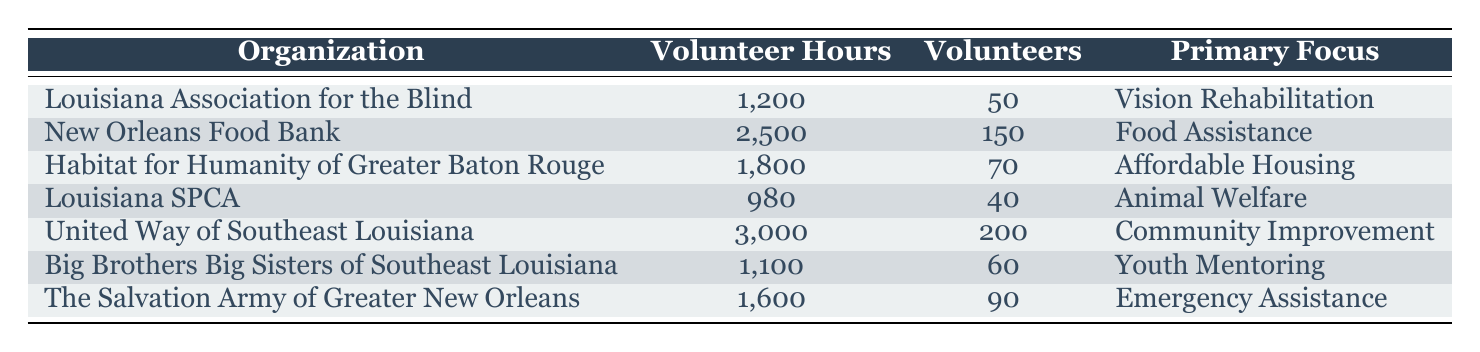What organization contributed the most volunteer hours? The table shows the total volunteer hours for each organization. By comparing them, United Way of Southeast Louisiana has the highest total of 3,000 volunteer hours.
Answer: United Way of Southeast Louisiana How many volunteer hours did the Louisiana SPCA contribute? According to the table, the Louisiana SPCA contributed a total of 980 volunteer hours.
Answer: 980 What is the total number of volunteers across all organizations? To find the total number of volunteers, we add the number of volunteers from each organization: 50 + 150 + 70 + 40 + 200 + 60 + 90 = 660.
Answer: 660 Which organization has the lowest number of volunteer hours? By reviewing the total volunteer hours listed, Louisiana SPCA has the lowest with 980 hours.
Answer: Louisiana SPCA Is it true that Habitat for Humanity of Greater Baton Rouge has more volunteers than the Louisiana SPCA? The table shows that Habitat for Humanity has 70 volunteers while Louisiana SPCA has 40 volunteers. Therefore, it is true that Habitat for Humanity has more volunteers.
Answer: Yes What is the average number of volunteer hours contributed by the organizations in the table? First, we need to sum the total volunteer hours: 1200 + 2500 + 1800 + 980 + 3000 + 1100 + 1600 = 13180. Then, we divide by the number of organizations, which is 7, giving us an average of 13180 / 7 ≈ 1882.86.
Answer: Approximately 1882.86 How many more volunteer hours did the New Orleans Food Bank contribute compared to the Louisiana Association for the Blind? New Orleans Food Bank contributed 2500 hours while Louisiana Association for the Blind contributed 1200 hours. The difference is 2500 - 1200 = 1300 hours, meaning the Food Bank contributed 1300 more hours.
Answer: 1300 